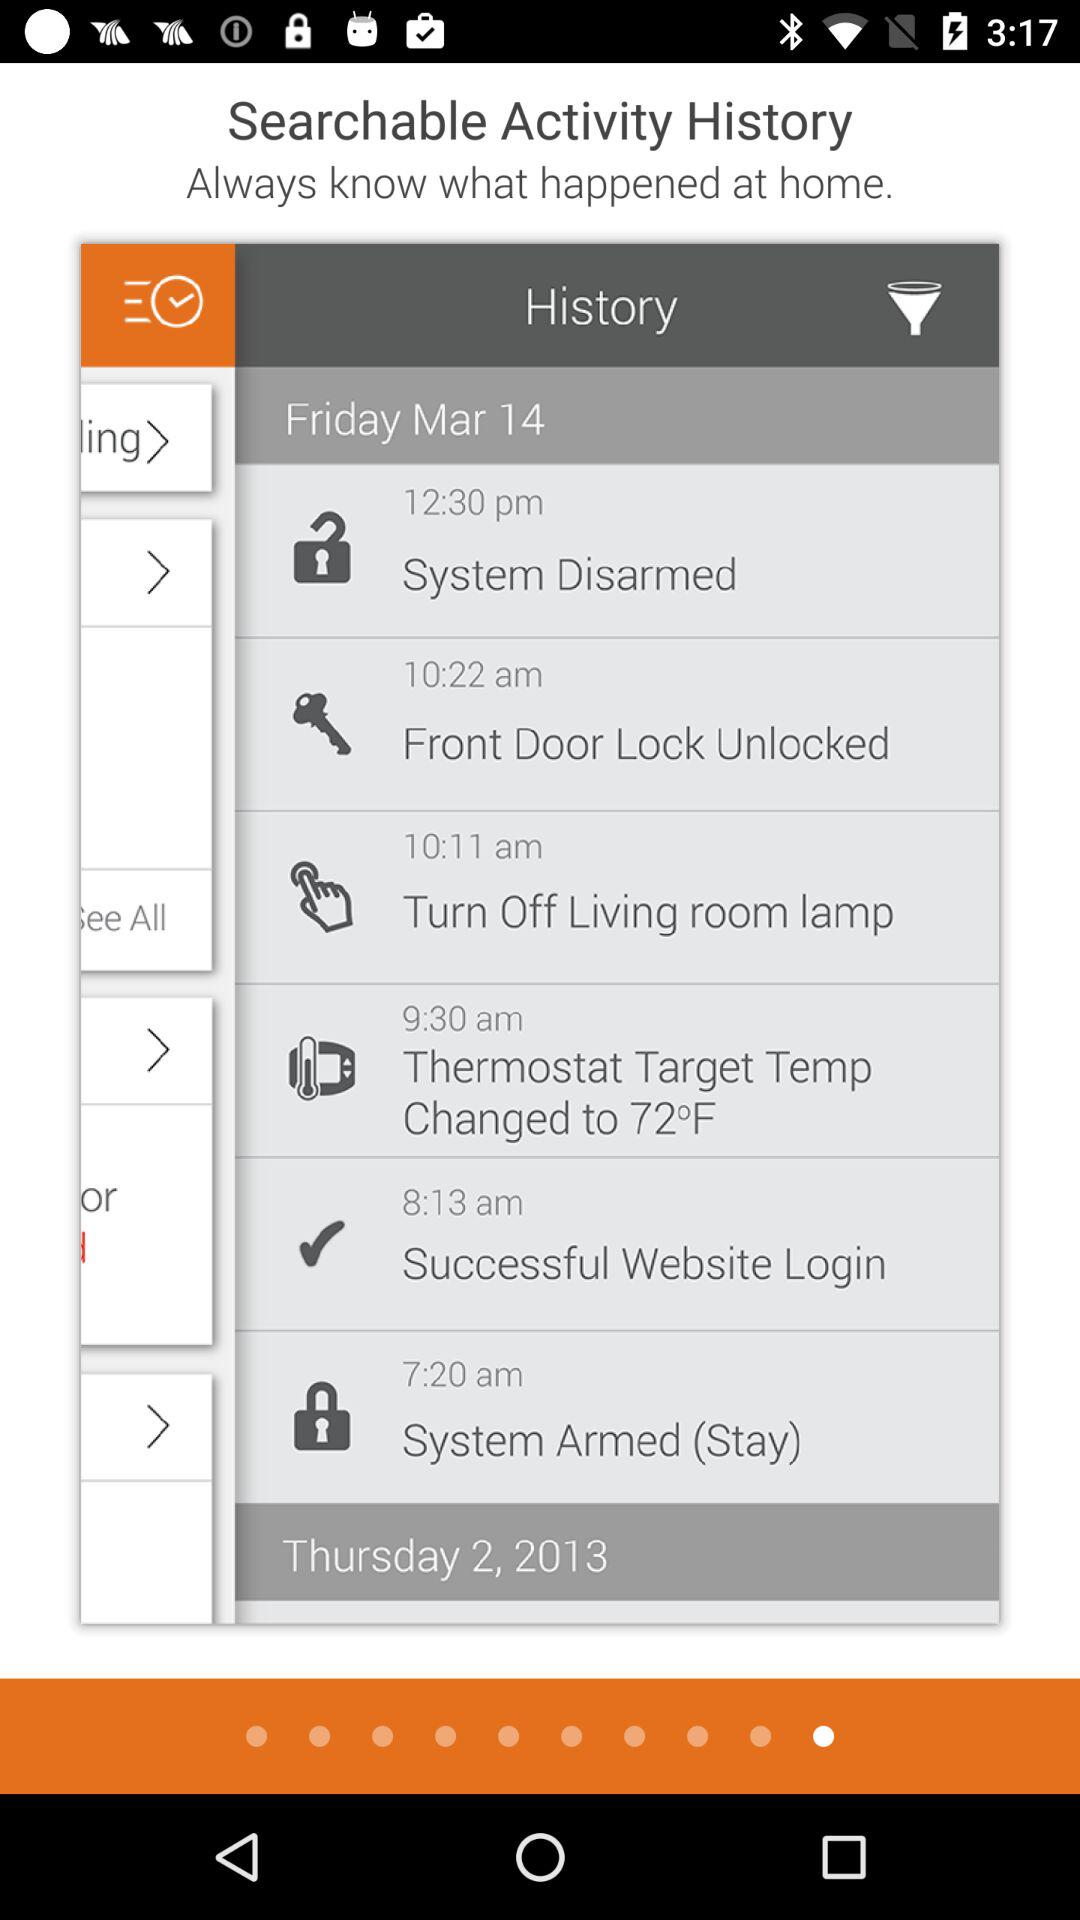At what time was the "System Disarmed"? The "System Disarmed" occurred at 12:30 p.m. 